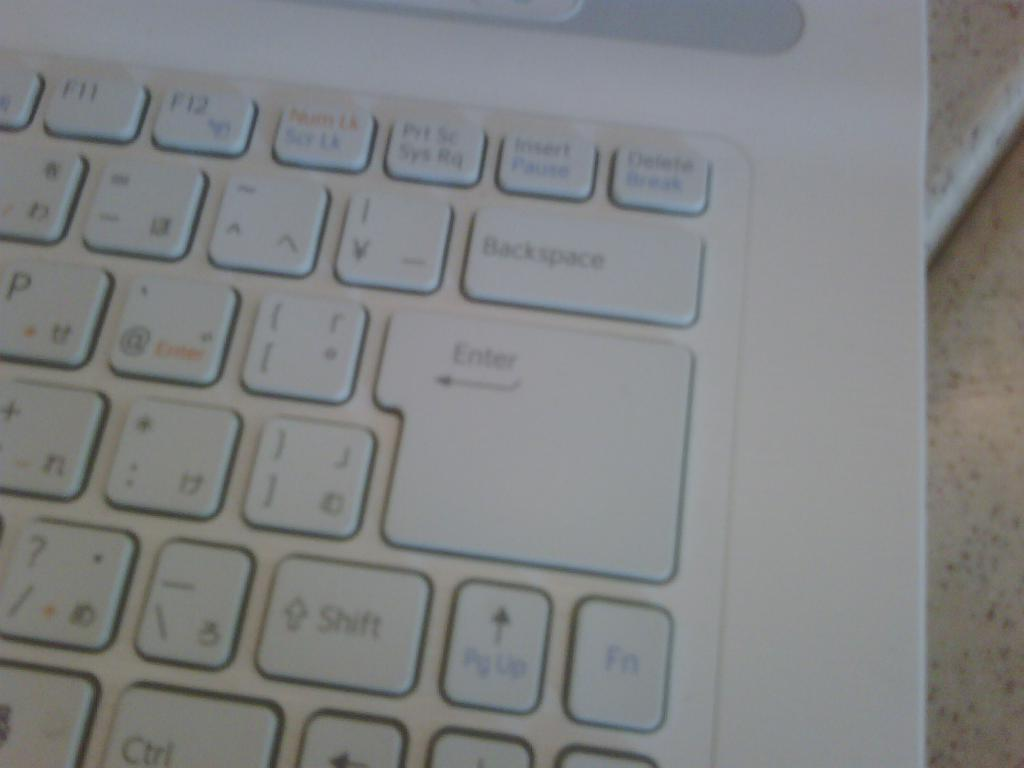Provide a one-sentence caption for the provided image. The enter key on the keyboard is two rows tall. 